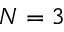Convert formula to latex. <formula><loc_0><loc_0><loc_500><loc_500>N = 3</formula> 